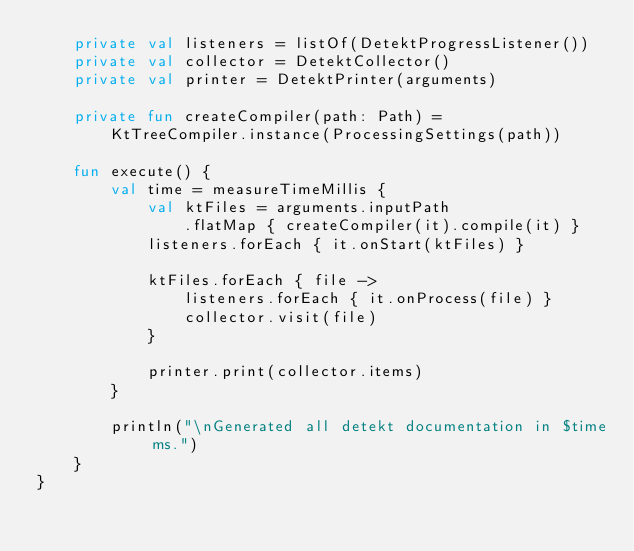Convert code to text. <code><loc_0><loc_0><loc_500><loc_500><_Kotlin_>    private val listeners = listOf(DetektProgressListener())
    private val collector = DetektCollector()
    private val printer = DetektPrinter(arguments)

    private fun createCompiler(path: Path) =
        KtTreeCompiler.instance(ProcessingSettings(path))

    fun execute() {
        val time = measureTimeMillis {
            val ktFiles = arguments.inputPath
                .flatMap { createCompiler(it).compile(it) }
            listeners.forEach { it.onStart(ktFiles) }

            ktFiles.forEach { file ->
                listeners.forEach { it.onProcess(file) }
                collector.visit(file)
            }

            printer.print(collector.items)
        }

        println("\nGenerated all detekt documentation in $time ms.")
    }
}
</code> 